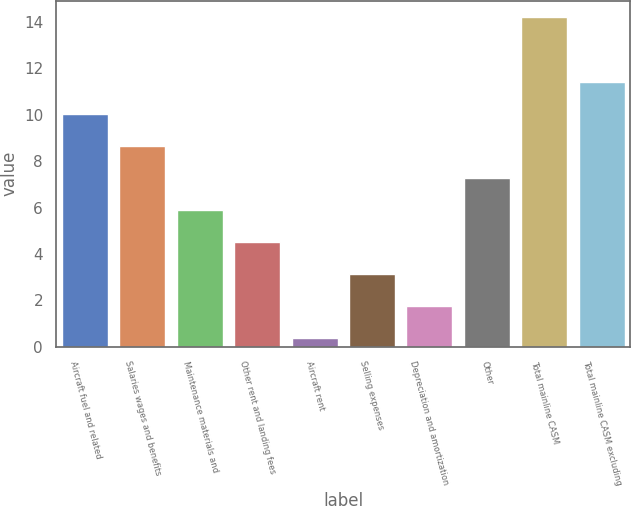Convert chart. <chart><loc_0><loc_0><loc_500><loc_500><bar_chart><fcel>Aircraft fuel and related<fcel>Salaries wages and benefits<fcel>Maintenance materials and<fcel>Other rent and landing fees<fcel>Aircraft rent<fcel>Selling expenses<fcel>Depreciation and amortization<fcel>Other<fcel>Total mainline CASM<fcel>Total mainline CASM excluding<nl><fcel>10.02<fcel>8.64<fcel>5.88<fcel>4.5<fcel>0.36<fcel>3.12<fcel>1.74<fcel>7.26<fcel>14.2<fcel>11.4<nl></chart> 